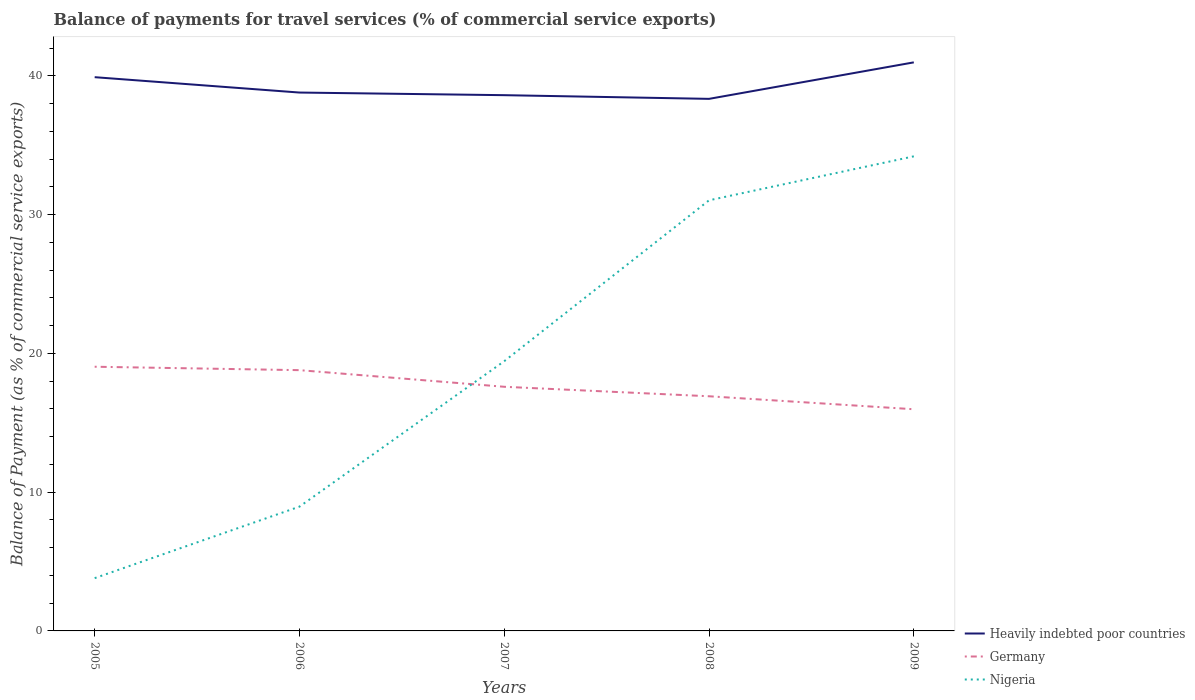How many different coloured lines are there?
Provide a succinct answer. 3. Across all years, what is the maximum balance of payments for travel services in Heavily indebted poor countries?
Offer a terse response. 38.34. What is the total balance of payments for travel services in Heavily indebted poor countries in the graph?
Give a very brief answer. 0.19. What is the difference between the highest and the second highest balance of payments for travel services in Germany?
Provide a succinct answer. 3.06. What is the difference between the highest and the lowest balance of payments for travel services in Heavily indebted poor countries?
Keep it short and to the point. 2. How many years are there in the graph?
Provide a short and direct response. 5. What is the difference between two consecutive major ticks on the Y-axis?
Your answer should be compact. 10. Does the graph contain any zero values?
Provide a succinct answer. No. Where does the legend appear in the graph?
Keep it short and to the point. Bottom right. How many legend labels are there?
Make the answer very short. 3. What is the title of the graph?
Your answer should be very brief. Balance of payments for travel services (% of commercial service exports). Does "Tuvalu" appear as one of the legend labels in the graph?
Provide a succinct answer. No. What is the label or title of the Y-axis?
Your response must be concise. Balance of Payment (as % of commercial service exports). What is the Balance of Payment (as % of commercial service exports) in Heavily indebted poor countries in 2005?
Your answer should be very brief. 39.9. What is the Balance of Payment (as % of commercial service exports) of Germany in 2005?
Keep it short and to the point. 19.04. What is the Balance of Payment (as % of commercial service exports) in Nigeria in 2005?
Keep it short and to the point. 3.8. What is the Balance of Payment (as % of commercial service exports) in Heavily indebted poor countries in 2006?
Your answer should be compact. 38.79. What is the Balance of Payment (as % of commercial service exports) in Germany in 2006?
Offer a very short reply. 18.79. What is the Balance of Payment (as % of commercial service exports) of Nigeria in 2006?
Offer a very short reply. 8.96. What is the Balance of Payment (as % of commercial service exports) of Heavily indebted poor countries in 2007?
Your response must be concise. 38.6. What is the Balance of Payment (as % of commercial service exports) of Germany in 2007?
Give a very brief answer. 17.59. What is the Balance of Payment (as % of commercial service exports) of Nigeria in 2007?
Your response must be concise. 19.44. What is the Balance of Payment (as % of commercial service exports) in Heavily indebted poor countries in 2008?
Your answer should be very brief. 38.34. What is the Balance of Payment (as % of commercial service exports) in Germany in 2008?
Your response must be concise. 16.91. What is the Balance of Payment (as % of commercial service exports) of Nigeria in 2008?
Ensure brevity in your answer.  31.03. What is the Balance of Payment (as % of commercial service exports) of Heavily indebted poor countries in 2009?
Your answer should be compact. 40.97. What is the Balance of Payment (as % of commercial service exports) in Germany in 2009?
Your response must be concise. 15.97. What is the Balance of Payment (as % of commercial service exports) of Nigeria in 2009?
Keep it short and to the point. 34.2. Across all years, what is the maximum Balance of Payment (as % of commercial service exports) of Heavily indebted poor countries?
Make the answer very short. 40.97. Across all years, what is the maximum Balance of Payment (as % of commercial service exports) in Germany?
Ensure brevity in your answer.  19.04. Across all years, what is the maximum Balance of Payment (as % of commercial service exports) of Nigeria?
Your response must be concise. 34.2. Across all years, what is the minimum Balance of Payment (as % of commercial service exports) in Heavily indebted poor countries?
Offer a terse response. 38.34. Across all years, what is the minimum Balance of Payment (as % of commercial service exports) in Germany?
Your answer should be very brief. 15.97. Across all years, what is the minimum Balance of Payment (as % of commercial service exports) of Nigeria?
Make the answer very short. 3.8. What is the total Balance of Payment (as % of commercial service exports) in Heavily indebted poor countries in the graph?
Offer a very short reply. 196.61. What is the total Balance of Payment (as % of commercial service exports) in Germany in the graph?
Your answer should be very brief. 88.3. What is the total Balance of Payment (as % of commercial service exports) in Nigeria in the graph?
Offer a very short reply. 97.42. What is the difference between the Balance of Payment (as % of commercial service exports) of Heavily indebted poor countries in 2005 and that in 2006?
Your answer should be very brief. 1.11. What is the difference between the Balance of Payment (as % of commercial service exports) in Germany in 2005 and that in 2006?
Keep it short and to the point. 0.25. What is the difference between the Balance of Payment (as % of commercial service exports) in Nigeria in 2005 and that in 2006?
Offer a terse response. -5.15. What is the difference between the Balance of Payment (as % of commercial service exports) of Heavily indebted poor countries in 2005 and that in 2007?
Offer a very short reply. 1.3. What is the difference between the Balance of Payment (as % of commercial service exports) in Germany in 2005 and that in 2007?
Make the answer very short. 1.44. What is the difference between the Balance of Payment (as % of commercial service exports) in Nigeria in 2005 and that in 2007?
Your response must be concise. -15.63. What is the difference between the Balance of Payment (as % of commercial service exports) in Heavily indebted poor countries in 2005 and that in 2008?
Keep it short and to the point. 1.56. What is the difference between the Balance of Payment (as % of commercial service exports) in Germany in 2005 and that in 2008?
Offer a terse response. 2.13. What is the difference between the Balance of Payment (as % of commercial service exports) in Nigeria in 2005 and that in 2008?
Provide a succinct answer. -27.23. What is the difference between the Balance of Payment (as % of commercial service exports) in Heavily indebted poor countries in 2005 and that in 2009?
Offer a terse response. -1.07. What is the difference between the Balance of Payment (as % of commercial service exports) in Germany in 2005 and that in 2009?
Your response must be concise. 3.06. What is the difference between the Balance of Payment (as % of commercial service exports) in Nigeria in 2005 and that in 2009?
Your answer should be very brief. -30.4. What is the difference between the Balance of Payment (as % of commercial service exports) of Heavily indebted poor countries in 2006 and that in 2007?
Provide a succinct answer. 0.19. What is the difference between the Balance of Payment (as % of commercial service exports) of Germany in 2006 and that in 2007?
Ensure brevity in your answer.  1.2. What is the difference between the Balance of Payment (as % of commercial service exports) of Nigeria in 2006 and that in 2007?
Your response must be concise. -10.48. What is the difference between the Balance of Payment (as % of commercial service exports) in Heavily indebted poor countries in 2006 and that in 2008?
Make the answer very short. 0.46. What is the difference between the Balance of Payment (as % of commercial service exports) in Germany in 2006 and that in 2008?
Provide a succinct answer. 1.88. What is the difference between the Balance of Payment (as % of commercial service exports) in Nigeria in 2006 and that in 2008?
Ensure brevity in your answer.  -22.07. What is the difference between the Balance of Payment (as % of commercial service exports) in Heavily indebted poor countries in 2006 and that in 2009?
Provide a short and direct response. -2.17. What is the difference between the Balance of Payment (as % of commercial service exports) of Germany in 2006 and that in 2009?
Your answer should be very brief. 2.82. What is the difference between the Balance of Payment (as % of commercial service exports) of Nigeria in 2006 and that in 2009?
Your response must be concise. -25.24. What is the difference between the Balance of Payment (as % of commercial service exports) of Heavily indebted poor countries in 2007 and that in 2008?
Ensure brevity in your answer.  0.27. What is the difference between the Balance of Payment (as % of commercial service exports) in Germany in 2007 and that in 2008?
Your response must be concise. 0.68. What is the difference between the Balance of Payment (as % of commercial service exports) in Nigeria in 2007 and that in 2008?
Make the answer very short. -11.59. What is the difference between the Balance of Payment (as % of commercial service exports) in Heavily indebted poor countries in 2007 and that in 2009?
Your answer should be very brief. -2.36. What is the difference between the Balance of Payment (as % of commercial service exports) in Germany in 2007 and that in 2009?
Ensure brevity in your answer.  1.62. What is the difference between the Balance of Payment (as % of commercial service exports) in Nigeria in 2007 and that in 2009?
Make the answer very short. -14.76. What is the difference between the Balance of Payment (as % of commercial service exports) in Heavily indebted poor countries in 2008 and that in 2009?
Offer a terse response. -2.63. What is the difference between the Balance of Payment (as % of commercial service exports) in Germany in 2008 and that in 2009?
Offer a very short reply. 0.94. What is the difference between the Balance of Payment (as % of commercial service exports) of Nigeria in 2008 and that in 2009?
Keep it short and to the point. -3.17. What is the difference between the Balance of Payment (as % of commercial service exports) in Heavily indebted poor countries in 2005 and the Balance of Payment (as % of commercial service exports) in Germany in 2006?
Keep it short and to the point. 21.11. What is the difference between the Balance of Payment (as % of commercial service exports) in Heavily indebted poor countries in 2005 and the Balance of Payment (as % of commercial service exports) in Nigeria in 2006?
Your answer should be compact. 30.95. What is the difference between the Balance of Payment (as % of commercial service exports) in Germany in 2005 and the Balance of Payment (as % of commercial service exports) in Nigeria in 2006?
Offer a very short reply. 10.08. What is the difference between the Balance of Payment (as % of commercial service exports) in Heavily indebted poor countries in 2005 and the Balance of Payment (as % of commercial service exports) in Germany in 2007?
Provide a succinct answer. 22.31. What is the difference between the Balance of Payment (as % of commercial service exports) of Heavily indebted poor countries in 2005 and the Balance of Payment (as % of commercial service exports) of Nigeria in 2007?
Keep it short and to the point. 20.47. What is the difference between the Balance of Payment (as % of commercial service exports) in Germany in 2005 and the Balance of Payment (as % of commercial service exports) in Nigeria in 2007?
Ensure brevity in your answer.  -0.4. What is the difference between the Balance of Payment (as % of commercial service exports) in Heavily indebted poor countries in 2005 and the Balance of Payment (as % of commercial service exports) in Germany in 2008?
Offer a very short reply. 22.99. What is the difference between the Balance of Payment (as % of commercial service exports) of Heavily indebted poor countries in 2005 and the Balance of Payment (as % of commercial service exports) of Nigeria in 2008?
Your response must be concise. 8.87. What is the difference between the Balance of Payment (as % of commercial service exports) in Germany in 2005 and the Balance of Payment (as % of commercial service exports) in Nigeria in 2008?
Provide a succinct answer. -11.99. What is the difference between the Balance of Payment (as % of commercial service exports) in Heavily indebted poor countries in 2005 and the Balance of Payment (as % of commercial service exports) in Germany in 2009?
Your response must be concise. 23.93. What is the difference between the Balance of Payment (as % of commercial service exports) in Heavily indebted poor countries in 2005 and the Balance of Payment (as % of commercial service exports) in Nigeria in 2009?
Your answer should be compact. 5.7. What is the difference between the Balance of Payment (as % of commercial service exports) of Germany in 2005 and the Balance of Payment (as % of commercial service exports) of Nigeria in 2009?
Keep it short and to the point. -15.16. What is the difference between the Balance of Payment (as % of commercial service exports) in Heavily indebted poor countries in 2006 and the Balance of Payment (as % of commercial service exports) in Germany in 2007?
Your answer should be compact. 21.2. What is the difference between the Balance of Payment (as % of commercial service exports) of Heavily indebted poor countries in 2006 and the Balance of Payment (as % of commercial service exports) of Nigeria in 2007?
Offer a terse response. 19.36. What is the difference between the Balance of Payment (as % of commercial service exports) in Germany in 2006 and the Balance of Payment (as % of commercial service exports) in Nigeria in 2007?
Your answer should be very brief. -0.65. What is the difference between the Balance of Payment (as % of commercial service exports) in Heavily indebted poor countries in 2006 and the Balance of Payment (as % of commercial service exports) in Germany in 2008?
Give a very brief answer. 21.89. What is the difference between the Balance of Payment (as % of commercial service exports) in Heavily indebted poor countries in 2006 and the Balance of Payment (as % of commercial service exports) in Nigeria in 2008?
Your response must be concise. 7.76. What is the difference between the Balance of Payment (as % of commercial service exports) in Germany in 2006 and the Balance of Payment (as % of commercial service exports) in Nigeria in 2008?
Make the answer very short. -12.24. What is the difference between the Balance of Payment (as % of commercial service exports) of Heavily indebted poor countries in 2006 and the Balance of Payment (as % of commercial service exports) of Germany in 2009?
Your answer should be very brief. 22.82. What is the difference between the Balance of Payment (as % of commercial service exports) of Heavily indebted poor countries in 2006 and the Balance of Payment (as % of commercial service exports) of Nigeria in 2009?
Your answer should be very brief. 4.6. What is the difference between the Balance of Payment (as % of commercial service exports) of Germany in 2006 and the Balance of Payment (as % of commercial service exports) of Nigeria in 2009?
Your answer should be compact. -15.41. What is the difference between the Balance of Payment (as % of commercial service exports) in Heavily indebted poor countries in 2007 and the Balance of Payment (as % of commercial service exports) in Germany in 2008?
Your answer should be compact. 21.7. What is the difference between the Balance of Payment (as % of commercial service exports) in Heavily indebted poor countries in 2007 and the Balance of Payment (as % of commercial service exports) in Nigeria in 2008?
Your answer should be compact. 7.58. What is the difference between the Balance of Payment (as % of commercial service exports) of Germany in 2007 and the Balance of Payment (as % of commercial service exports) of Nigeria in 2008?
Offer a terse response. -13.44. What is the difference between the Balance of Payment (as % of commercial service exports) of Heavily indebted poor countries in 2007 and the Balance of Payment (as % of commercial service exports) of Germany in 2009?
Keep it short and to the point. 22.63. What is the difference between the Balance of Payment (as % of commercial service exports) of Heavily indebted poor countries in 2007 and the Balance of Payment (as % of commercial service exports) of Nigeria in 2009?
Your response must be concise. 4.41. What is the difference between the Balance of Payment (as % of commercial service exports) of Germany in 2007 and the Balance of Payment (as % of commercial service exports) of Nigeria in 2009?
Your response must be concise. -16.61. What is the difference between the Balance of Payment (as % of commercial service exports) of Heavily indebted poor countries in 2008 and the Balance of Payment (as % of commercial service exports) of Germany in 2009?
Provide a short and direct response. 22.37. What is the difference between the Balance of Payment (as % of commercial service exports) of Heavily indebted poor countries in 2008 and the Balance of Payment (as % of commercial service exports) of Nigeria in 2009?
Your answer should be very brief. 4.14. What is the difference between the Balance of Payment (as % of commercial service exports) of Germany in 2008 and the Balance of Payment (as % of commercial service exports) of Nigeria in 2009?
Make the answer very short. -17.29. What is the average Balance of Payment (as % of commercial service exports) of Heavily indebted poor countries per year?
Offer a terse response. 39.32. What is the average Balance of Payment (as % of commercial service exports) of Germany per year?
Your answer should be compact. 17.66. What is the average Balance of Payment (as % of commercial service exports) of Nigeria per year?
Ensure brevity in your answer.  19.48. In the year 2005, what is the difference between the Balance of Payment (as % of commercial service exports) in Heavily indebted poor countries and Balance of Payment (as % of commercial service exports) in Germany?
Your answer should be compact. 20.86. In the year 2005, what is the difference between the Balance of Payment (as % of commercial service exports) of Heavily indebted poor countries and Balance of Payment (as % of commercial service exports) of Nigeria?
Keep it short and to the point. 36.1. In the year 2005, what is the difference between the Balance of Payment (as % of commercial service exports) in Germany and Balance of Payment (as % of commercial service exports) in Nigeria?
Give a very brief answer. 15.23. In the year 2006, what is the difference between the Balance of Payment (as % of commercial service exports) of Heavily indebted poor countries and Balance of Payment (as % of commercial service exports) of Germany?
Your response must be concise. 20. In the year 2006, what is the difference between the Balance of Payment (as % of commercial service exports) in Heavily indebted poor countries and Balance of Payment (as % of commercial service exports) in Nigeria?
Keep it short and to the point. 29.84. In the year 2006, what is the difference between the Balance of Payment (as % of commercial service exports) of Germany and Balance of Payment (as % of commercial service exports) of Nigeria?
Offer a very short reply. 9.83. In the year 2007, what is the difference between the Balance of Payment (as % of commercial service exports) of Heavily indebted poor countries and Balance of Payment (as % of commercial service exports) of Germany?
Offer a terse response. 21.01. In the year 2007, what is the difference between the Balance of Payment (as % of commercial service exports) in Heavily indebted poor countries and Balance of Payment (as % of commercial service exports) in Nigeria?
Provide a succinct answer. 19.17. In the year 2007, what is the difference between the Balance of Payment (as % of commercial service exports) in Germany and Balance of Payment (as % of commercial service exports) in Nigeria?
Your answer should be compact. -1.84. In the year 2008, what is the difference between the Balance of Payment (as % of commercial service exports) in Heavily indebted poor countries and Balance of Payment (as % of commercial service exports) in Germany?
Provide a short and direct response. 21.43. In the year 2008, what is the difference between the Balance of Payment (as % of commercial service exports) of Heavily indebted poor countries and Balance of Payment (as % of commercial service exports) of Nigeria?
Offer a terse response. 7.31. In the year 2008, what is the difference between the Balance of Payment (as % of commercial service exports) in Germany and Balance of Payment (as % of commercial service exports) in Nigeria?
Give a very brief answer. -14.12. In the year 2009, what is the difference between the Balance of Payment (as % of commercial service exports) in Heavily indebted poor countries and Balance of Payment (as % of commercial service exports) in Germany?
Provide a short and direct response. 25. In the year 2009, what is the difference between the Balance of Payment (as % of commercial service exports) of Heavily indebted poor countries and Balance of Payment (as % of commercial service exports) of Nigeria?
Keep it short and to the point. 6.77. In the year 2009, what is the difference between the Balance of Payment (as % of commercial service exports) in Germany and Balance of Payment (as % of commercial service exports) in Nigeria?
Provide a short and direct response. -18.22. What is the ratio of the Balance of Payment (as % of commercial service exports) of Heavily indebted poor countries in 2005 to that in 2006?
Provide a short and direct response. 1.03. What is the ratio of the Balance of Payment (as % of commercial service exports) of Germany in 2005 to that in 2006?
Offer a terse response. 1.01. What is the ratio of the Balance of Payment (as % of commercial service exports) in Nigeria in 2005 to that in 2006?
Ensure brevity in your answer.  0.42. What is the ratio of the Balance of Payment (as % of commercial service exports) in Heavily indebted poor countries in 2005 to that in 2007?
Give a very brief answer. 1.03. What is the ratio of the Balance of Payment (as % of commercial service exports) of Germany in 2005 to that in 2007?
Ensure brevity in your answer.  1.08. What is the ratio of the Balance of Payment (as % of commercial service exports) of Nigeria in 2005 to that in 2007?
Provide a short and direct response. 0.2. What is the ratio of the Balance of Payment (as % of commercial service exports) of Heavily indebted poor countries in 2005 to that in 2008?
Make the answer very short. 1.04. What is the ratio of the Balance of Payment (as % of commercial service exports) of Germany in 2005 to that in 2008?
Provide a short and direct response. 1.13. What is the ratio of the Balance of Payment (as % of commercial service exports) in Nigeria in 2005 to that in 2008?
Your answer should be compact. 0.12. What is the ratio of the Balance of Payment (as % of commercial service exports) of Heavily indebted poor countries in 2005 to that in 2009?
Offer a terse response. 0.97. What is the ratio of the Balance of Payment (as % of commercial service exports) in Germany in 2005 to that in 2009?
Make the answer very short. 1.19. What is the ratio of the Balance of Payment (as % of commercial service exports) in Nigeria in 2005 to that in 2009?
Provide a succinct answer. 0.11. What is the ratio of the Balance of Payment (as % of commercial service exports) in Germany in 2006 to that in 2007?
Provide a succinct answer. 1.07. What is the ratio of the Balance of Payment (as % of commercial service exports) in Nigeria in 2006 to that in 2007?
Offer a terse response. 0.46. What is the ratio of the Balance of Payment (as % of commercial service exports) of Heavily indebted poor countries in 2006 to that in 2008?
Your response must be concise. 1.01. What is the ratio of the Balance of Payment (as % of commercial service exports) of Germany in 2006 to that in 2008?
Offer a very short reply. 1.11. What is the ratio of the Balance of Payment (as % of commercial service exports) of Nigeria in 2006 to that in 2008?
Your response must be concise. 0.29. What is the ratio of the Balance of Payment (as % of commercial service exports) of Heavily indebted poor countries in 2006 to that in 2009?
Make the answer very short. 0.95. What is the ratio of the Balance of Payment (as % of commercial service exports) of Germany in 2006 to that in 2009?
Give a very brief answer. 1.18. What is the ratio of the Balance of Payment (as % of commercial service exports) of Nigeria in 2006 to that in 2009?
Your answer should be compact. 0.26. What is the ratio of the Balance of Payment (as % of commercial service exports) in Germany in 2007 to that in 2008?
Keep it short and to the point. 1.04. What is the ratio of the Balance of Payment (as % of commercial service exports) in Nigeria in 2007 to that in 2008?
Make the answer very short. 0.63. What is the ratio of the Balance of Payment (as % of commercial service exports) of Heavily indebted poor countries in 2007 to that in 2009?
Offer a terse response. 0.94. What is the ratio of the Balance of Payment (as % of commercial service exports) in Germany in 2007 to that in 2009?
Your response must be concise. 1.1. What is the ratio of the Balance of Payment (as % of commercial service exports) in Nigeria in 2007 to that in 2009?
Give a very brief answer. 0.57. What is the ratio of the Balance of Payment (as % of commercial service exports) in Heavily indebted poor countries in 2008 to that in 2009?
Offer a terse response. 0.94. What is the ratio of the Balance of Payment (as % of commercial service exports) in Germany in 2008 to that in 2009?
Provide a succinct answer. 1.06. What is the ratio of the Balance of Payment (as % of commercial service exports) in Nigeria in 2008 to that in 2009?
Provide a succinct answer. 0.91. What is the difference between the highest and the second highest Balance of Payment (as % of commercial service exports) of Heavily indebted poor countries?
Make the answer very short. 1.07. What is the difference between the highest and the second highest Balance of Payment (as % of commercial service exports) in Germany?
Give a very brief answer. 0.25. What is the difference between the highest and the second highest Balance of Payment (as % of commercial service exports) of Nigeria?
Your answer should be very brief. 3.17. What is the difference between the highest and the lowest Balance of Payment (as % of commercial service exports) in Heavily indebted poor countries?
Your response must be concise. 2.63. What is the difference between the highest and the lowest Balance of Payment (as % of commercial service exports) in Germany?
Ensure brevity in your answer.  3.06. What is the difference between the highest and the lowest Balance of Payment (as % of commercial service exports) of Nigeria?
Your answer should be compact. 30.4. 